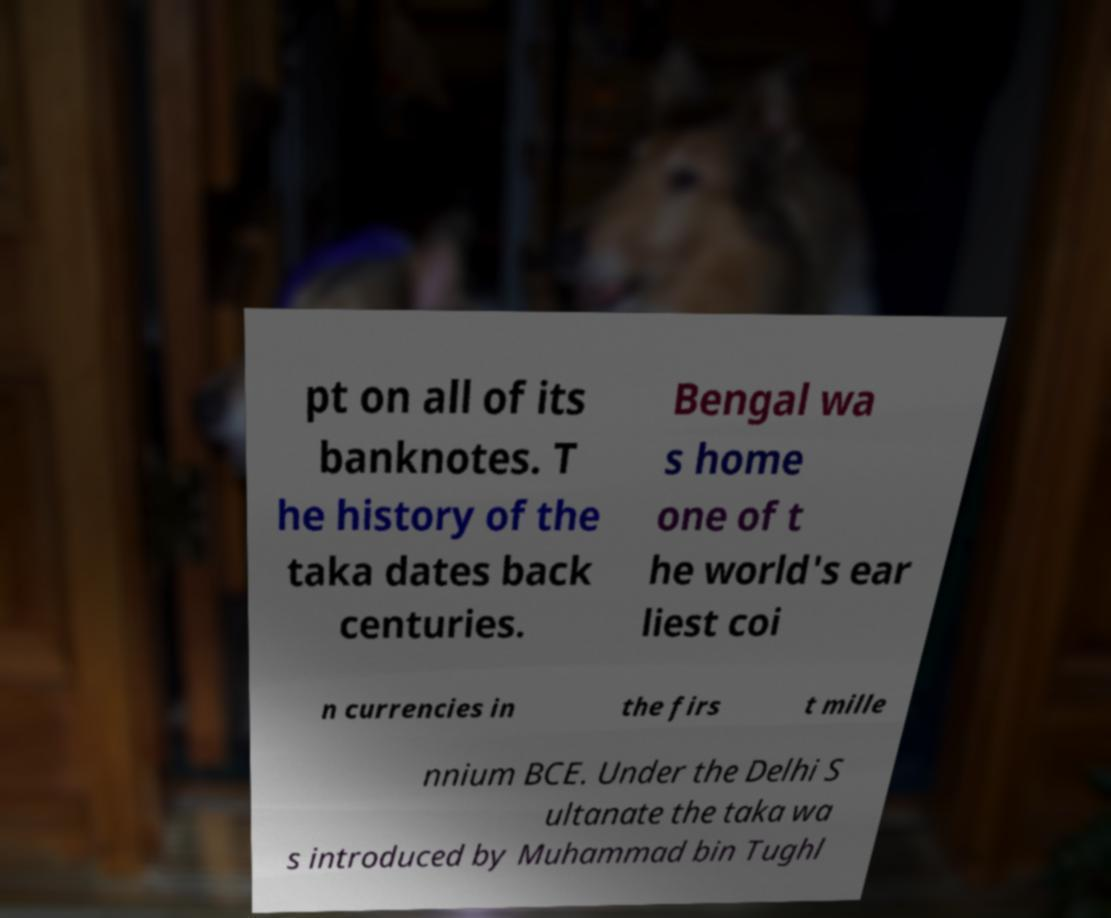Can you accurately transcribe the text from the provided image for me? pt on all of its banknotes. T he history of the taka dates back centuries. Bengal wa s home one of t he world's ear liest coi n currencies in the firs t mille nnium BCE. Under the Delhi S ultanate the taka wa s introduced by Muhammad bin Tughl 